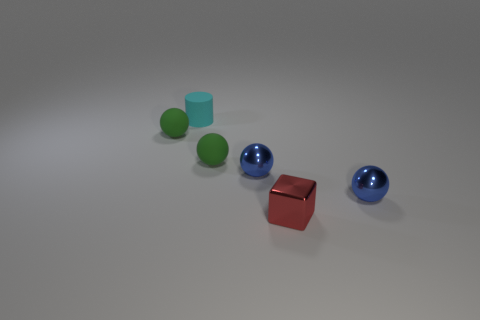Is there a green object made of the same material as the tiny cyan thing?
Keep it short and to the point. Yes. What is the small object that is on the left side of the tiny cyan cylinder on the left side of the red thing made of?
Keep it short and to the point. Rubber. What is the shape of the small red metal object?
Offer a terse response. Cube. Are there fewer big brown rubber cylinders than green matte balls?
Your response must be concise. Yes. Are there more tiny balls than metallic objects?
Keep it short and to the point. Yes. Is the cube made of the same material as the tiny blue thing that is left of the small red metal object?
Provide a short and direct response. Yes. There is a small rubber ball that is on the left side of the green sphere on the right side of the cyan object; how many red things are behind it?
Your answer should be very brief. 0. Is the number of shiny objects on the left side of the cyan matte thing less than the number of small blue metallic things on the right side of the red cube?
Provide a succinct answer. Yes. How many other things are there of the same material as the tiny red cube?
Your response must be concise. 2. There is a cyan object that is the same size as the red block; what is its material?
Offer a terse response. Rubber. 